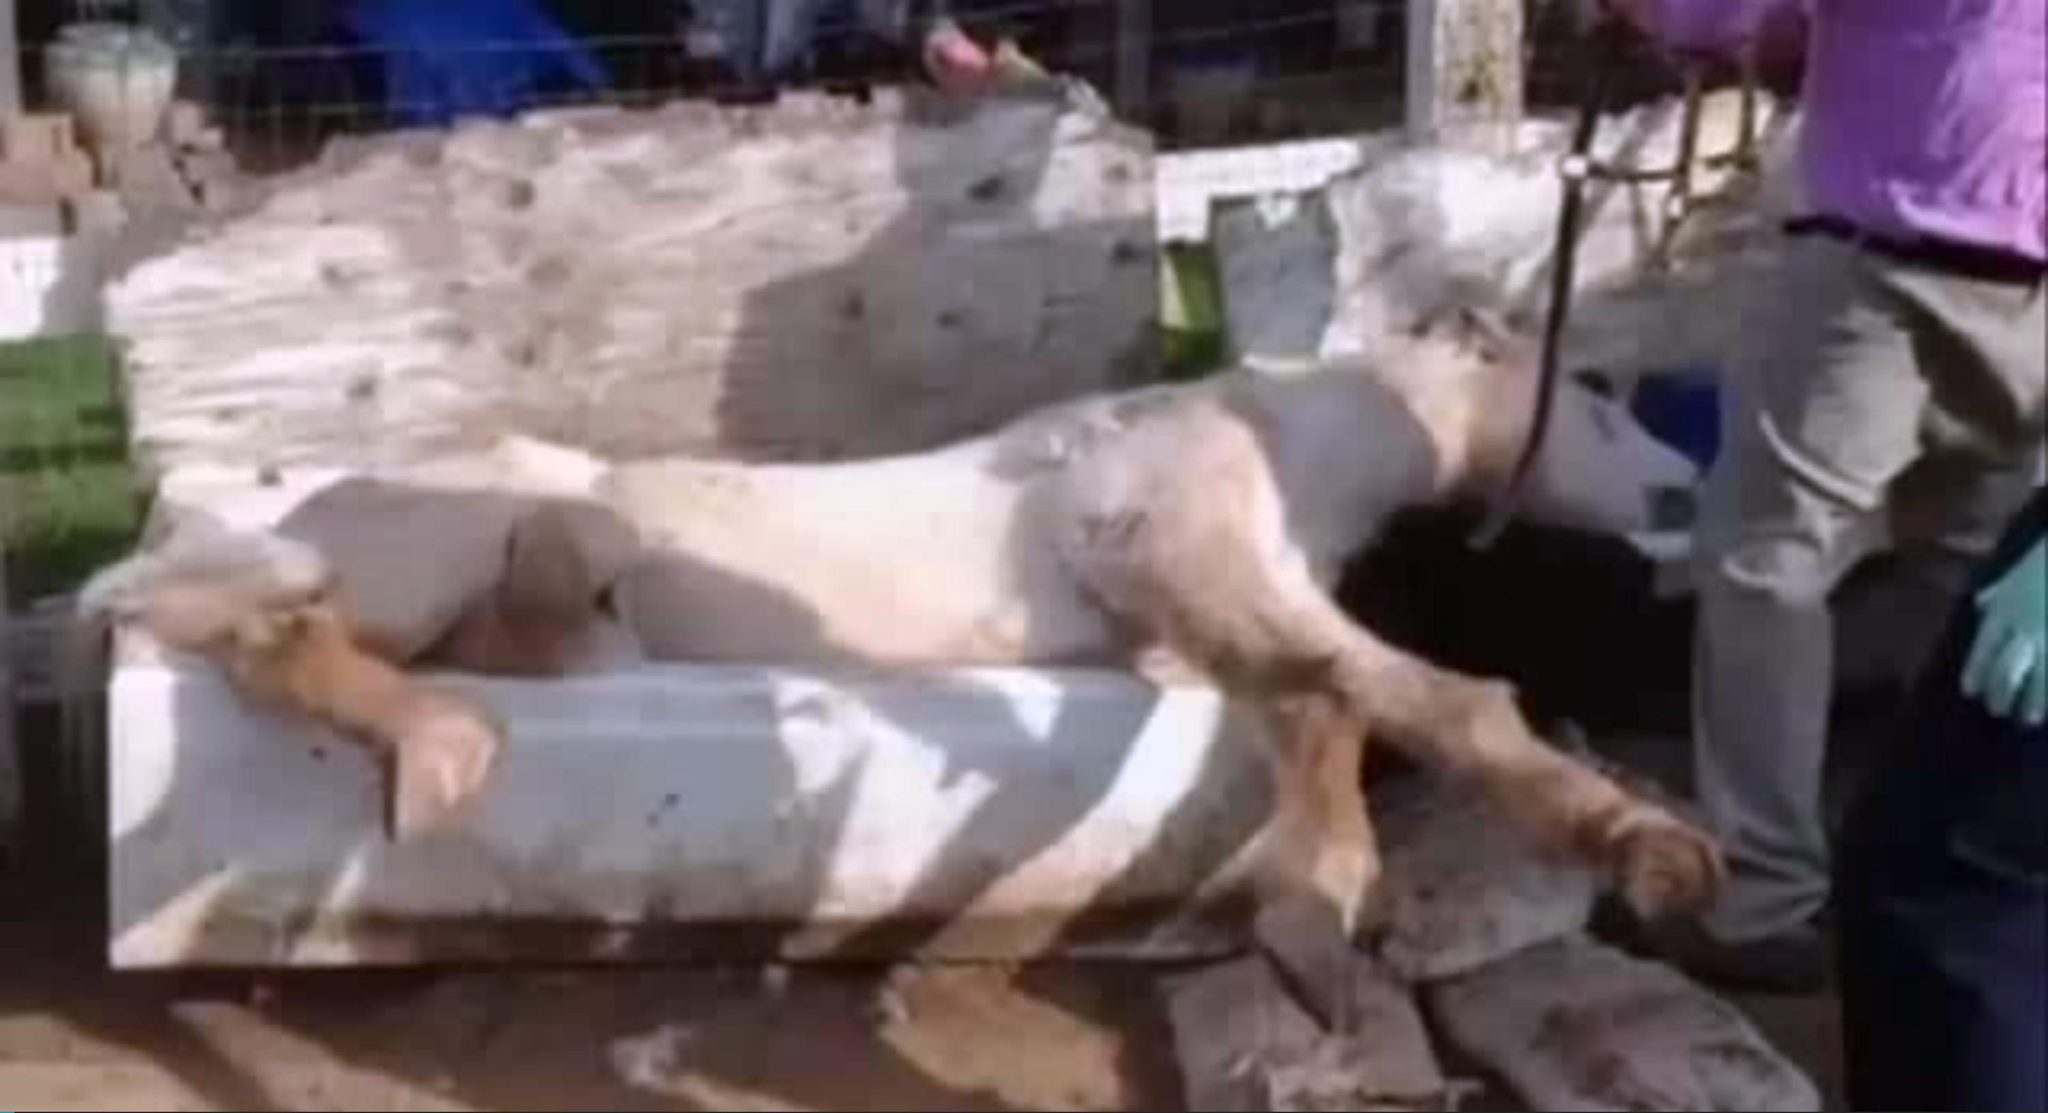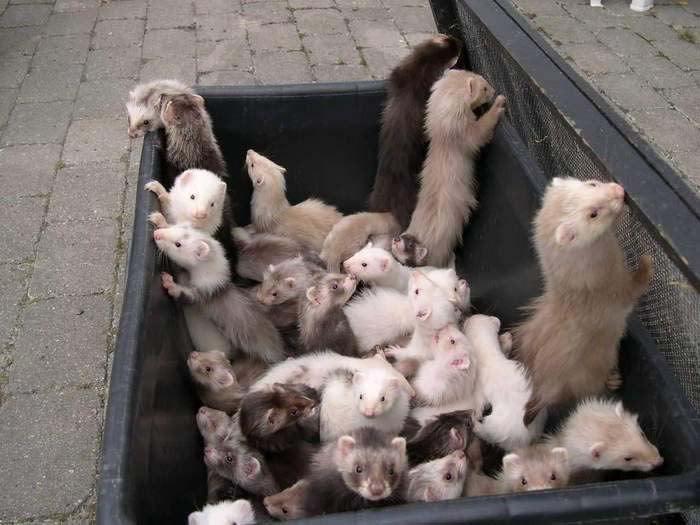The first image is the image on the left, the second image is the image on the right. Examine the images to the left and right. Is the description "The right image contains one ferret emerging from a hole in the dirt." accurate? Answer yes or no. No. 